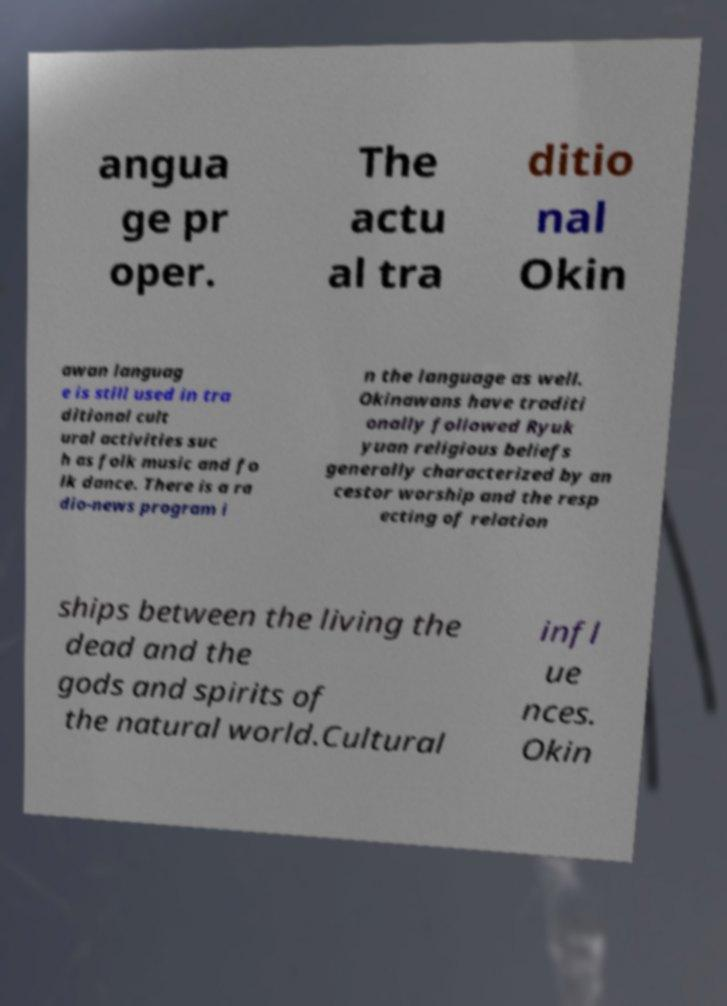Could you assist in decoding the text presented in this image and type it out clearly? angua ge pr oper. The actu al tra ditio nal Okin awan languag e is still used in tra ditional cult ural activities suc h as folk music and fo lk dance. There is a ra dio-news program i n the language as well. Okinawans have traditi onally followed Ryuk yuan religious beliefs generally characterized by an cestor worship and the resp ecting of relation ships between the living the dead and the gods and spirits of the natural world.Cultural infl ue nces. Okin 